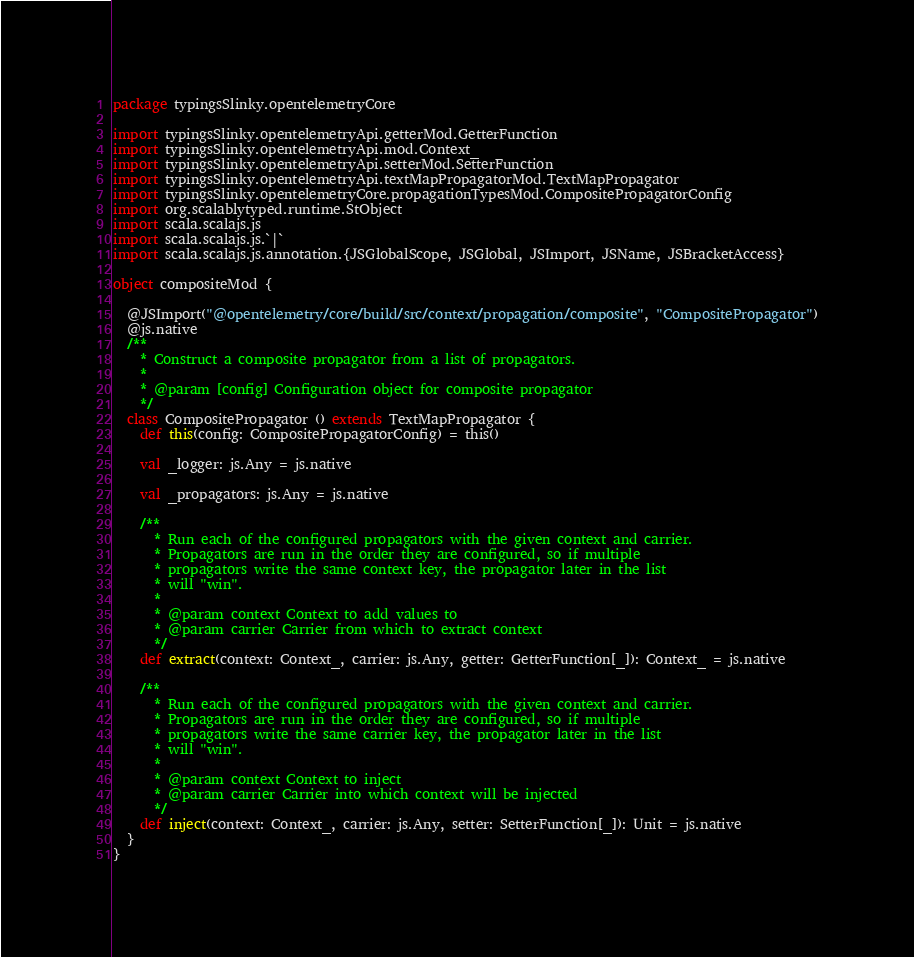Convert code to text. <code><loc_0><loc_0><loc_500><loc_500><_Scala_>package typingsSlinky.opentelemetryCore

import typingsSlinky.opentelemetryApi.getterMod.GetterFunction
import typingsSlinky.opentelemetryApi.mod.Context_
import typingsSlinky.opentelemetryApi.setterMod.SetterFunction
import typingsSlinky.opentelemetryApi.textMapPropagatorMod.TextMapPropagator
import typingsSlinky.opentelemetryCore.propagationTypesMod.CompositePropagatorConfig
import org.scalablytyped.runtime.StObject
import scala.scalajs.js
import scala.scalajs.js.`|`
import scala.scalajs.js.annotation.{JSGlobalScope, JSGlobal, JSImport, JSName, JSBracketAccess}

object compositeMod {
  
  @JSImport("@opentelemetry/core/build/src/context/propagation/composite", "CompositePropagator")
  @js.native
  /**
    * Construct a composite propagator from a list of propagators.
    *
    * @param [config] Configuration object for composite propagator
    */
  class CompositePropagator () extends TextMapPropagator {
    def this(config: CompositePropagatorConfig) = this()
    
    val _logger: js.Any = js.native
    
    val _propagators: js.Any = js.native
    
    /**
      * Run each of the configured propagators with the given context and carrier.
      * Propagators are run in the order they are configured, so if multiple
      * propagators write the same context key, the propagator later in the list
      * will "win".
      *
      * @param context Context to add values to
      * @param carrier Carrier from which to extract context
      */
    def extract(context: Context_, carrier: js.Any, getter: GetterFunction[_]): Context_ = js.native
    
    /**
      * Run each of the configured propagators with the given context and carrier.
      * Propagators are run in the order they are configured, so if multiple
      * propagators write the same carrier key, the propagator later in the list
      * will "win".
      *
      * @param context Context to inject
      * @param carrier Carrier into which context will be injected
      */
    def inject(context: Context_, carrier: js.Any, setter: SetterFunction[_]): Unit = js.native
  }
}
</code> 